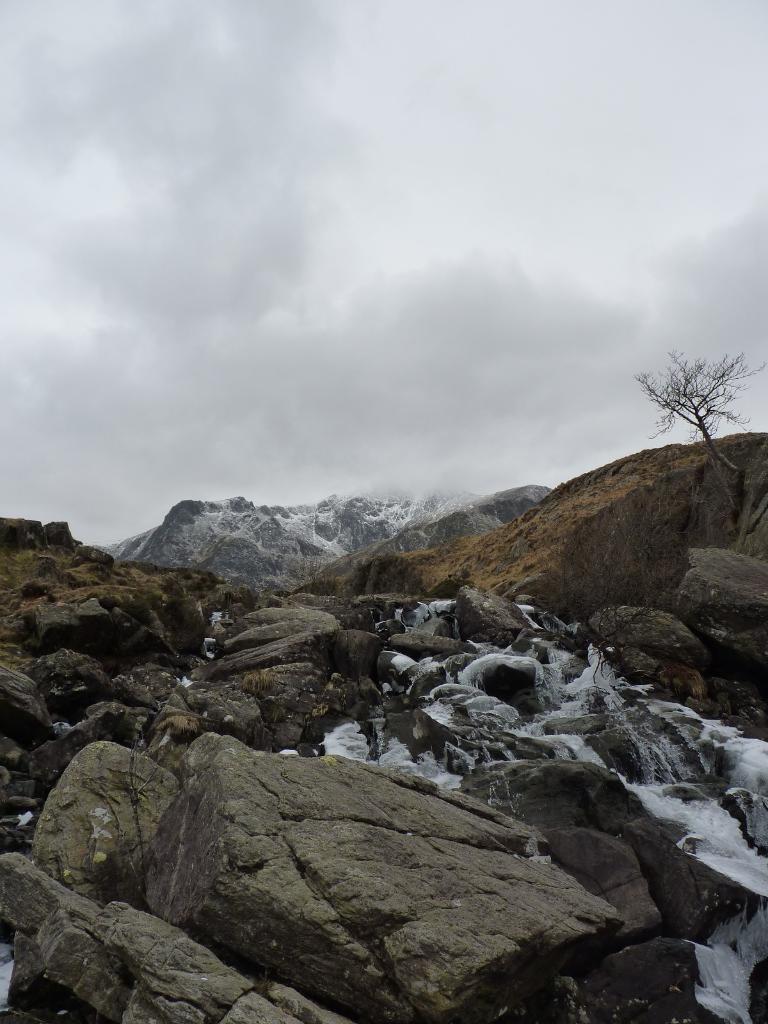Please provide a concise description of this image. In this picture there are rocks at the bottom side of the image and there is a dried plant on the right side of the image, there is sky at the top side of the image. 